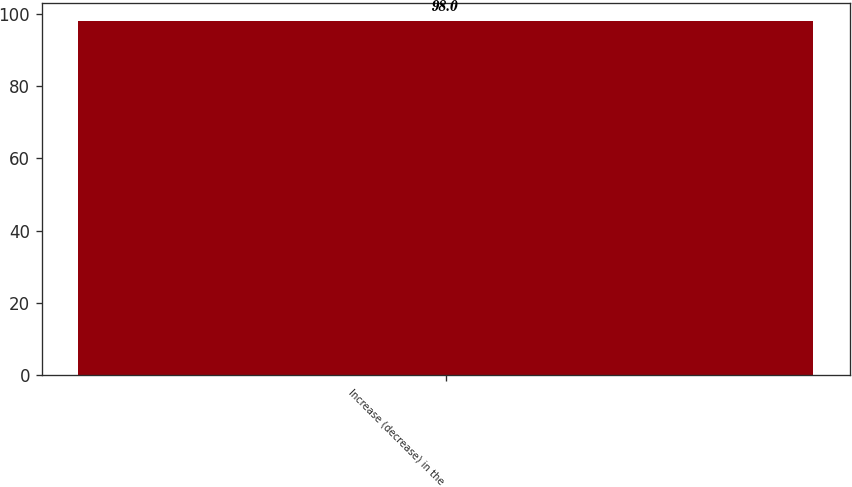<chart> <loc_0><loc_0><loc_500><loc_500><bar_chart><fcel>Increase (decrease) in the<nl><fcel>98<nl></chart> 